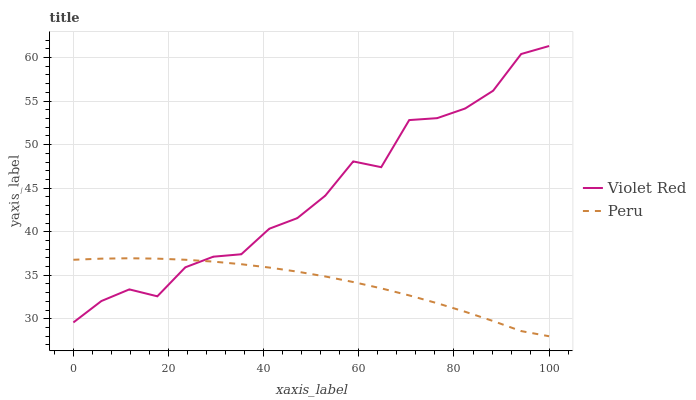Does Peru have the minimum area under the curve?
Answer yes or no. Yes. Does Violet Red have the maximum area under the curve?
Answer yes or no. Yes. Does Peru have the maximum area under the curve?
Answer yes or no. No. Is Peru the smoothest?
Answer yes or no. Yes. Is Violet Red the roughest?
Answer yes or no. Yes. Is Peru the roughest?
Answer yes or no. No. Does Peru have the lowest value?
Answer yes or no. Yes. Does Violet Red have the highest value?
Answer yes or no. Yes. Does Peru have the highest value?
Answer yes or no. No. Does Peru intersect Violet Red?
Answer yes or no. Yes. Is Peru less than Violet Red?
Answer yes or no. No. Is Peru greater than Violet Red?
Answer yes or no. No. 